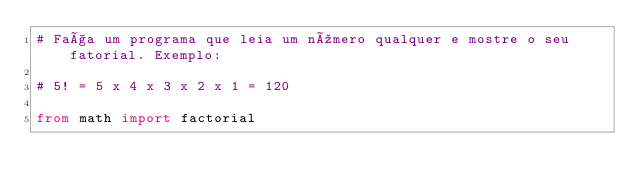<code> <loc_0><loc_0><loc_500><loc_500><_Python_># Faça um programa que leia um número qualquer e mostre o seu fatorial. Exemplo:

# 5! = 5 x 4 x 3 x 2 x 1 = 120

from math import factorial</code> 